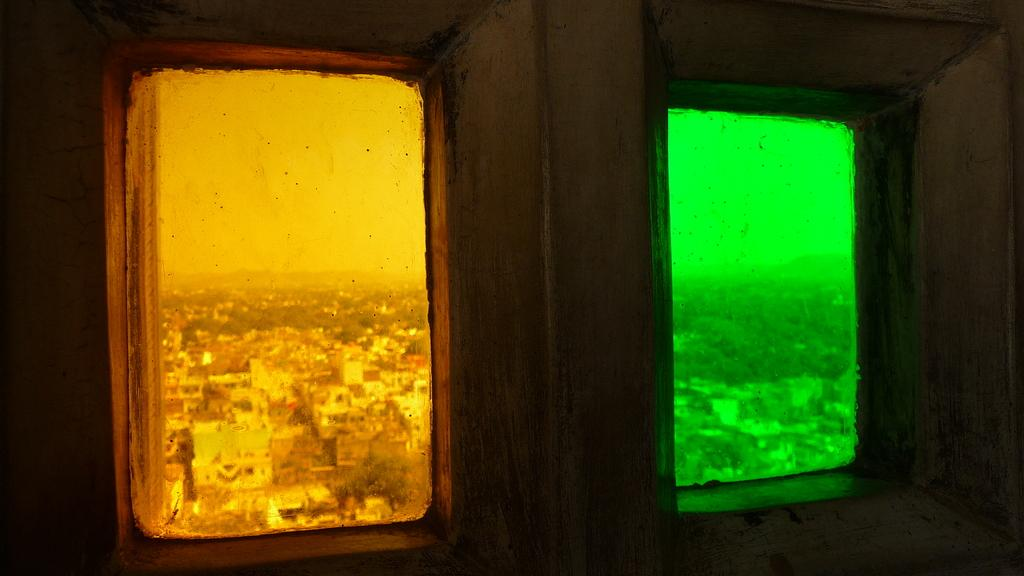What can be seen in the image that allows light to enter a room? There are windows in the image. What is visible in the distance behind the windows? There are buildings and trees in the background of the image. What is visible in the sky in the image? The sky is visible in the background of the image. What type of toothpaste is being used to clean the windows in the image? There is no toothpaste present in the image, and the windows are not being cleaned. Can you hear a whistle in the image? There is no whistle present in the image, and no sound can be heard. 